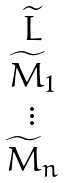Convert formula to latex. <formula><loc_0><loc_0><loc_500><loc_500>\begin{matrix} \widetilde { L } \\ \widetilde { M } _ { 1 } \\ \vdots \\ \widetilde { M } _ { n } \end{matrix}</formula> 